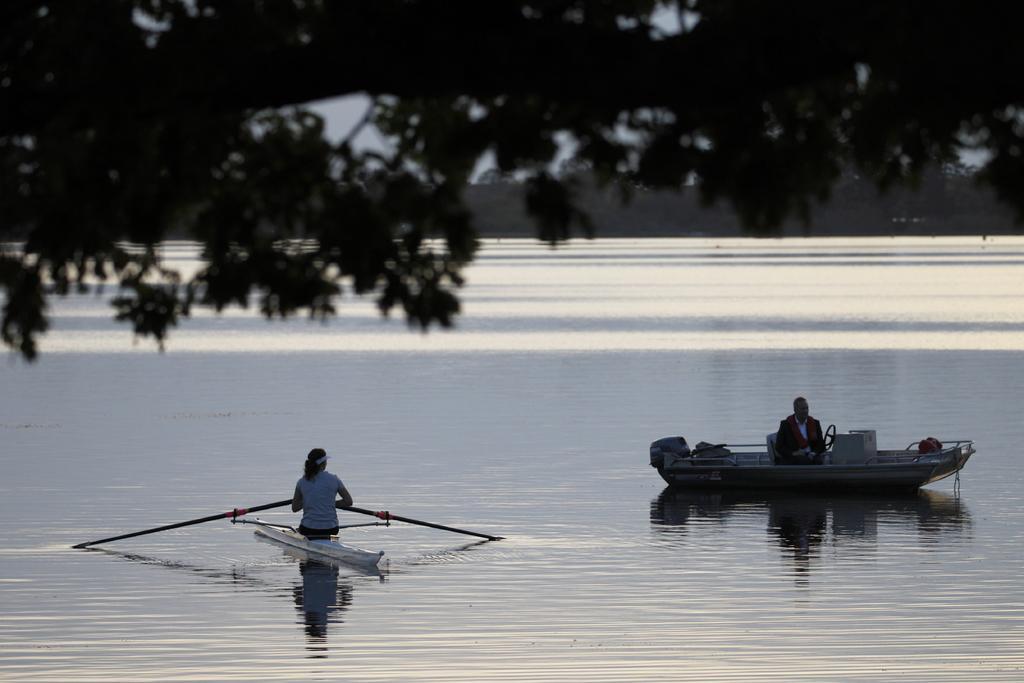Can you describe this image briefly? In this picture, on the right side, we can see a man is sitting on the boat. On the left side, we can also see a woman is sitting on the boat. In the background, we can see some trees. On the top, we can see some trees and a sky, at the bottom there is a water in a lake. 